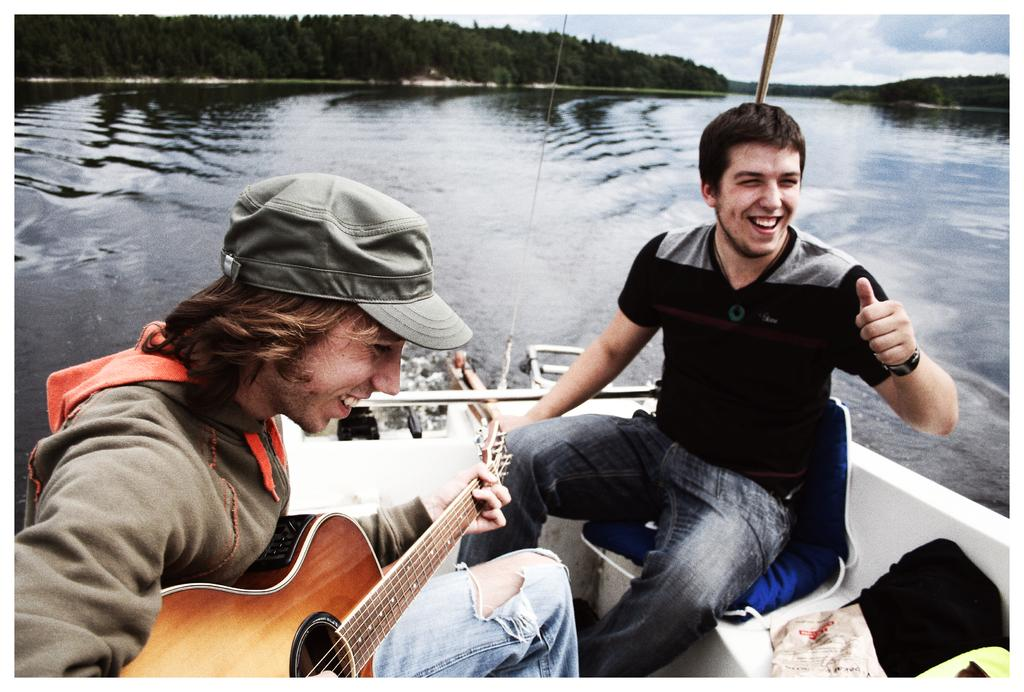How many people are in the image? There are two persons in the image. What are the persons doing in the image? The persons are sitting on a boat, and one of them is playing the guitar. What can be seen in the background of the image? There are trees and the sky visible in the image. What is the condition of the sky in the image? The sky is cloudy in the image. What type of oil can be seen dripping from the guitar in the image? There is no oil present in the image, and the guitar is not depicted as dripping anything. Is there a house visible in the image? No, there is no house present in the image; it features two persons on a boat with a guitar and a cloudy sky. 